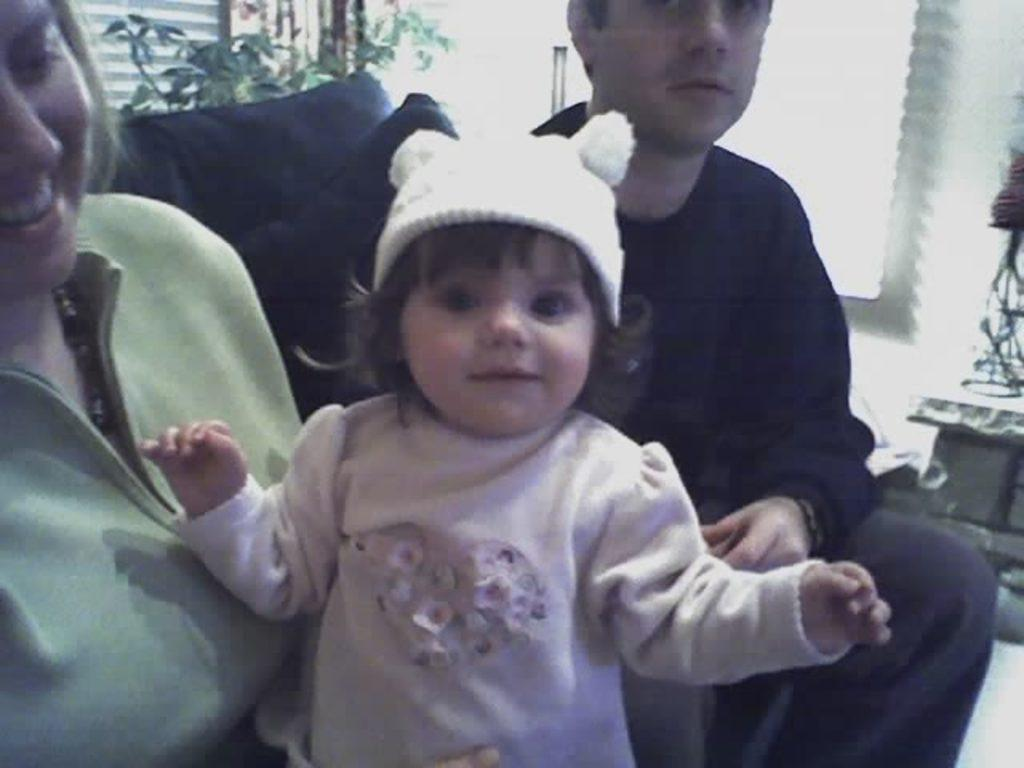Who is sitting on the left side of the image? There is a beautiful woman sitting on the left side of the image. What is happening in the middle of the image? There is a little baby laughing in the middle of the image. What is the baby wearing? The baby is wearing a sweater. Who is sitting on the right side of the image? There is a man sitting on the right side of the image. What type of quilt is being used by the secretary in the image? There is no secretary or quilt present in the image. What flavor of soda is the baby drinking in the image? There is no soda present in the image; the baby is laughing and wearing a sweater. 